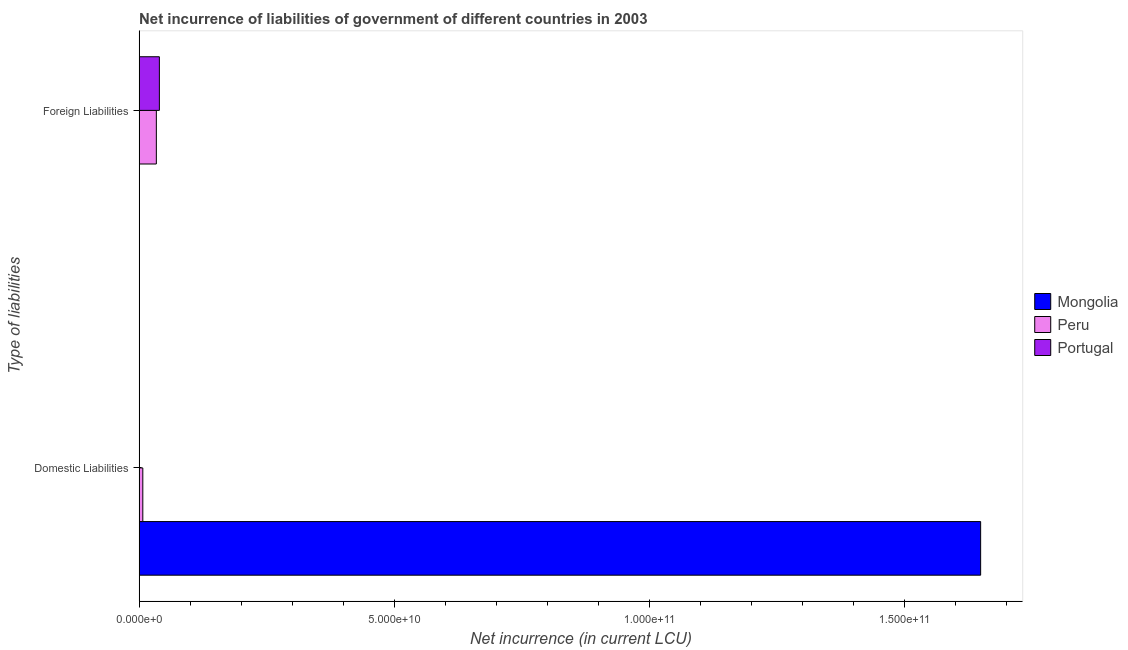How many different coloured bars are there?
Ensure brevity in your answer.  3. How many groups of bars are there?
Your answer should be very brief. 2. Are the number of bars per tick equal to the number of legend labels?
Make the answer very short. No. How many bars are there on the 1st tick from the bottom?
Make the answer very short. 3. What is the label of the 2nd group of bars from the top?
Offer a terse response. Domestic Liabilities. What is the net incurrence of domestic liabilities in Peru?
Your response must be concise. 7.27e+08. Across all countries, what is the maximum net incurrence of foreign liabilities?
Your response must be concise. 3.97e+09. Across all countries, what is the minimum net incurrence of domestic liabilities?
Offer a terse response. 1.68e+07. In which country was the net incurrence of domestic liabilities maximum?
Provide a succinct answer. Mongolia. What is the total net incurrence of domestic liabilities in the graph?
Ensure brevity in your answer.  1.66e+11. What is the difference between the net incurrence of domestic liabilities in Mongolia and that in Peru?
Keep it short and to the point. 1.64e+11. What is the difference between the net incurrence of foreign liabilities in Portugal and the net incurrence of domestic liabilities in Mongolia?
Offer a terse response. -1.61e+11. What is the average net incurrence of foreign liabilities per country?
Make the answer very short. 2.45e+09. What is the difference between the net incurrence of foreign liabilities and net incurrence of domestic liabilities in Peru?
Make the answer very short. 2.65e+09. What is the ratio of the net incurrence of domestic liabilities in Peru to that in Portugal?
Your response must be concise. 43.16. Is the net incurrence of domestic liabilities in Portugal less than that in Peru?
Your answer should be very brief. Yes. Are all the bars in the graph horizontal?
Ensure brevity in your answer.  Yes. How many countries are there in the graph?
Offer a very short reply. 3. What is the difference between two consecutive major ticks on the X-axis?
Provide a succinct answer. 5.00e+1. Are the values on the major ticks of X-axis written in scientific E-notation?
Keep it short and to the point. Yes. Does the graph contain any zero values?
Give a very brief answer. Yes. Does the graph contain grids?
Your answer should be compact. No. How are the legend labels stacked?
Your response must be concise. Vertical. What is the title of the graph?
Offer a very short reply. Net incurrence of liabilities of government of different countries in 2003. What is the label or title of the X-axis?
Give a very brief answer. Net incurrence (in current LCU). What is the label or title of the Y-axis?
Provide a short and direct response. Type of liabilities. What is the Net incurrence (in current LCU) in Mongolia in Domestic Liabilities?
Offer a very short reply. 1.65e+11. What is the Net incurrence (in current LCU) of Peru in Domestic Liabilities?
Your answer should be very brief. 7.27e+08. What is the Net incurrence (in current LCU) in Portugal in Domestic Liabilities?
Keep it short and to the point. 1.68e+07. What is the Net incurrence (in current LCU) of Peru in Foreign Liabilities?
Ensure brevity in your answer.  3.38e+09. What is the Net incurrence (in current LCU) of Portugal in Foreign Liabilities?
Your response must be concise. 3.97e+09. Across all Type of liabilities, what is the maximum Net incurrence (in current LCU) of Mongolia?
Offer a very short reply. 1.65e+11. Across all Type of liabilities, what is the maximum Net incurrence (in current LCU) in Peru?
Make the answer very short. 3.38e+09. Across all Type of liabilities, what is the maximum Net incurrence (in current LCU) of Portugal?
Keep it short and to the point. 3.97e+09. Across all Type of liabilities, what is the minimum Net incurrence (in current LCU) of Mongolia?
Your answer should be very brief. 0. Across all Type of liabilities, what is the minimum Net incurrence (in current LCU) in Peru?
Ensure brevity in your answer.  7.27e+08. Across all Type of liabilities, what is the minimum Net incurrence (in current LCU) of Portugal?
Your answer should be compact. 1.68e+07. What is the total Net incurrence (in current LCU) in Mongolia in the graph?
Make the answer very short. 1.65e+11. What is the total Net incurrence (in current LCU) in Peru in the graph?
Offer a very short reply. 4.10e+09. What is the total Net incurrence (in current LCU) in Portugal in the graph?
Your response must be concise. 3.99e+09. What is the difference between the Net incurrence (in current LCU) of Peru in Domestic Liabilities and that in Foreign Liabilities?
Keep it short and to the point. -2.65e+09. What is the difference between the Net incurrence (in current LCU) of Portugal in Domestic Liabilities and that in Foreign Liabilities?
Give a very brief answer. -3.96e+09. What is the difference between the Net incurrence (in current LCU) of Mongolia in Domestic Liabilities and the Net incurrence (in current LCU) of Peru in Foreign Liabilities?
Your response must be concise. 1.62e+11. What is the difference between the Net incurrence (in current LCU) in Mongolia in Domestic Liabilities and the Net incurrence (in current LCU) in Portugal in Foreign Liabilities?
Ensure brevity in your answer.  1.61e+11. What is the difference between the Net incurrence (in current LCU) in Peru in Domestic Liabilities and the Net incurrence (in current LCU) in Portugal in Foreign Liabilities?
Your response must be concise. -3.25e+09. What is the average Net incurrence (in current LCU) in Mongolia per Type of liabilities?
Offer a terse response. 8.24e+1. What is the average Net incurrence (in current LCU) of Peru per Type of liabilities?
Offer a very short reply. 2.05e+09. What is the average Net incurrence (in current LCU) in Portugal per Type of liabilities?
Your answer should be compact. 1.99e+09. What is the difference between the Net incurrence (in current LCU) in Mongolia and Net incurrence (in current LCU) in Peru in Domestic Liabilities?
Ensure brevity in your answer.  1.64e+11. What is the difference between the Net incurrence (in current LCU) of Mongolia and Net incurrence (in current LCU) of Portugal in Domestic Liabilities?
Your response must be concise. 1.65e+11. What is the difference between the Net incurrence (in current LCU) of Peru and Net incurrence (in current LCU) of Portugal in Domestic Liabilities?
Your response must be concise. 7.10e+08. What is the difference between the Net incurrence (in current LCU) of Peru and Net incurrence (in current LCU) of Portugal in Foreign Liabilities?
Provide a succinct answer. -5.95e+08. What is the ratio of the Net incurrence (in current LCU) of Peru in Domestic Liabilities to that in Foreign Liabilities?
Offer a terse response. 0.22. What is the ratio of the Net incurrence (in current LCU) in Portugal in Domestic Liabilities to that in Foreign Liabilities?
Provide a short and direct response. 0. What is the difference between the highest and the second highest Net incurrence (in current LCU) in Peru?
Your answer should be compact. 2.65e+09. What is the difference between the highest and the second highest Net incurrence (in current LCU) of Portugal?
Offer a very short reply. 3.96e+09. What is the difference between the highest and the lowest Net incurrence (in current LCU) of Mongolia?
Your answer should be compact. 1.65e+11. What is the difference between the highest and the lowest Net incurrence (in current LCU) in Peru?
Give a very brief answer. 2.65e+09. What is the difference between the highest and the lowest Net incurrence (in current LCU) of Portugal?
Keep it short and to the point. 3.96e+09. 